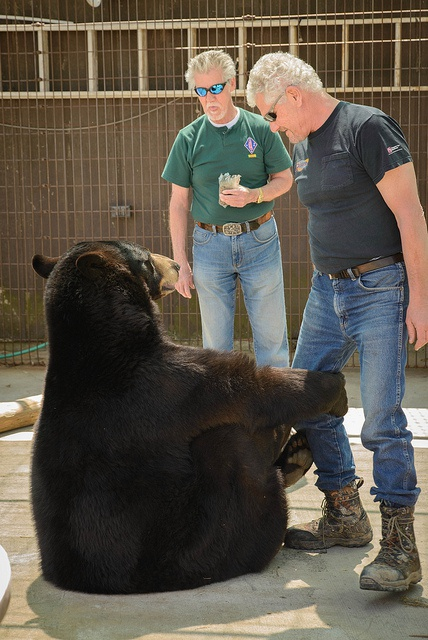Describe the objects in this image and their specific colors. I can see bear in black and gray tones, people in black, gray, darkblue, and salmon tones, and people in black, darkgray, teal, and tan tones in this image. 